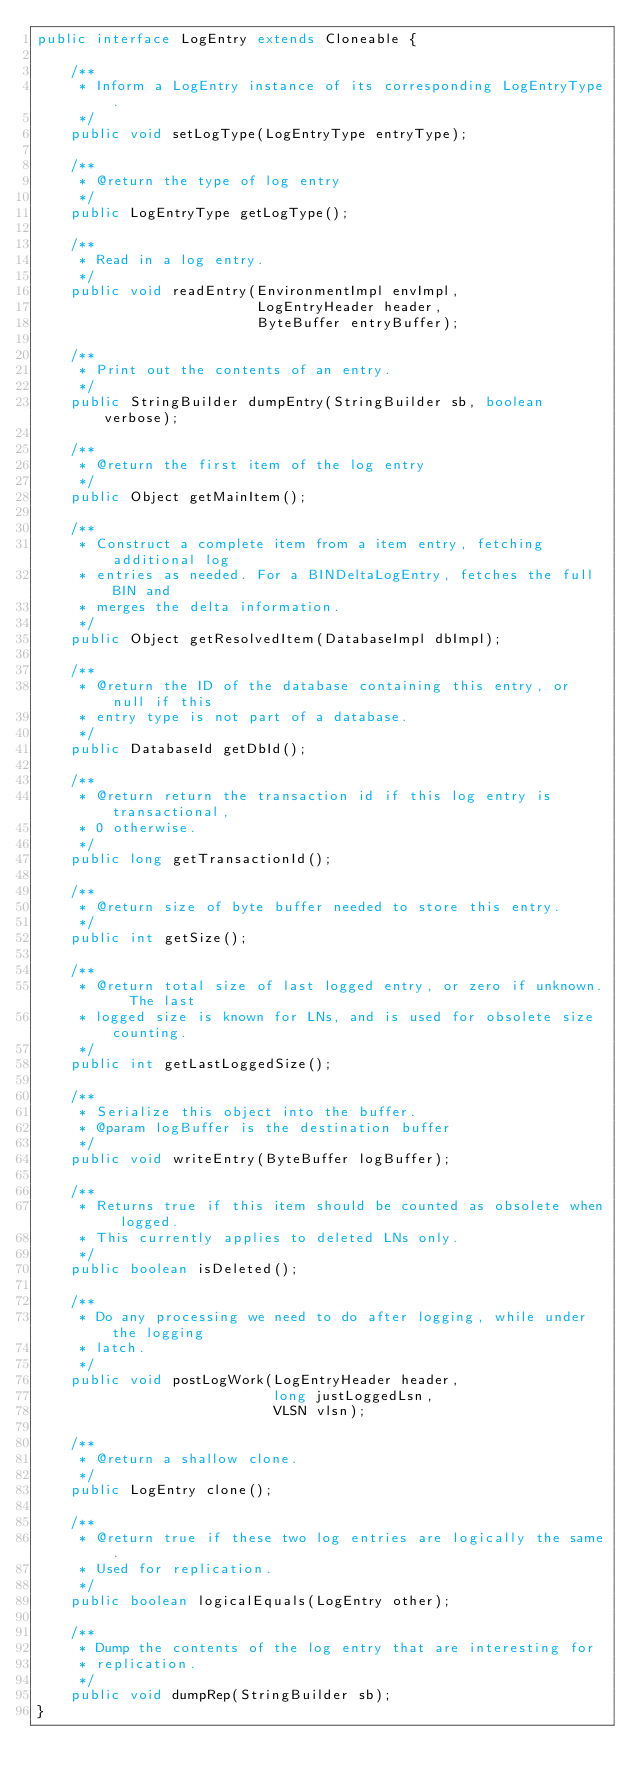Convert code to text. <code><loc_0><loc_0><loc_500><loc_500><_Java_>public interface LogEntry extends Cloneable {

    /**
     * Inform a LogEntry instance of its corresponding LogEntryType.
     */
    public void setLogType(LogEntryType entryType);

    /**
     * @return the type of log entry
     */
    public LogEntryType getLogType();

    /**
     * Read in a log entry.
     */
    public void readEntry(EnvironmentImpl envImpl,
                          LogEntryHeader header,
                          ByteBuffer entryBuffer);

    /**
     * Print out the contents of an entry.
     */
    public StringBuilder dumpEntry(StringBuilder sb, boolean verbose);

    /**
     * @return the first item of the log entry
     */
    public Object getMainItem();

    /**
     * Construct a complete item from a item entry, fetching additional log
     * entries as needed. For a BINDeltaLogEntry, fetches the full BIN and
     * merges the delta information.
     */
    public Object getResolvedItem(DatabaseImpl dbImpl);

    /**
     * @return the ID of the database containing this entry, or null if this
     * entry type is not part of a database.
     */
    public DatabaseId getDbId();

    /**
     * @return return the transaction id if this log entry is transactional,
     * 0 otherwise.
     */
    public long getTransactionId();

    /**
     * @return size of byte buffer needed to store this entry.
     */
    public int getSize();

    /**
     * @return total size of last logged entry, or zero if unknown.  The last
     * logged size is known for LNs, and is used for obsolete size counting.
     */
    public int getLastLoggedSize();

    /**
     * Serialize this object into the buffer.
     * @param logBuffer is the destination buffer
     */
    public void writeEntry(ByteBuffer logBuffer);

    /**
     * Returns true if this item should be counted as obsolete when logged.
     * This currently applies to deleted LNs only.
     */
    public boolean isDeleted();

    /**
     * Do any processing we need to do after logging, while under the logging
     * latch.
     */
    public void postLogWork(LogEntryHeader header,
                            long justLoggedLsn,
                            VLSN vlsn);

    /**
     * @return a shallow clone.
     */
    public LogEntry clone();

    /**
     * @return true if these two log entries are logically the same.
     * Used for replication.
     */
    public boolean logicalEquals(LogEntry other);

    /**
     * Dump the contents of the log entry that are interesting for
     * replication.
     */
    public void dumpRep(StringBuilder sb);
}
</code> 